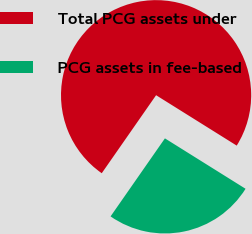Convert chart. <chart><loc_0><loc_0><loc_500><loc_500><pie_chart><fcel>Total PCG assets under<fcel>PCG assets in fee-based<nl><fcel>74.21%<fcel>25.79%<nl></chart> 